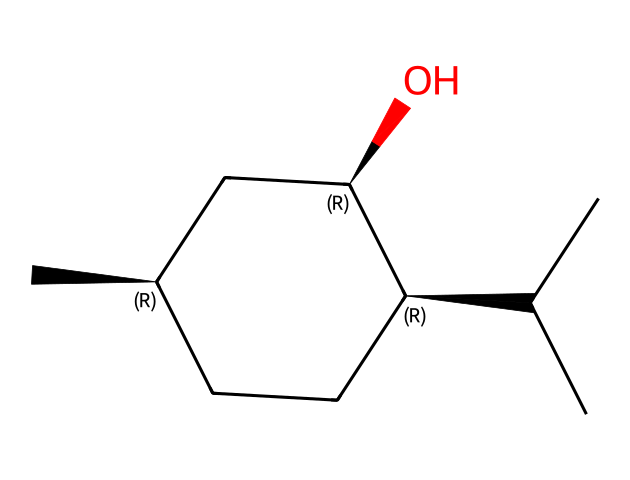How many carbon atoms are in menthol? The SMILES representation indicates 10 carbon atoms, which can be counted directly from the structure. Each "C" represents a carbon atom, and there are ten instances in total.
Answer: 10 What is the functional group present in menthol? The molecule contains a hydroxyl group (-OH) attached to one of the carbon atoms, indicating that it is an alcohol. The "O" in the SMILES structure signifies the presence of oxygen, and it's bonded to a carbon.
Answer: alcohol How many chiral centers are in menthol? By analyzing the structure, there are three chiral centers in menthol, indicated by the carbon atoms attached to four different groups or atoms. The sterochemistry indicators (@) in the SMILES represent these chiral centers.
Answer: 3 What type of stereoisomers can menthol exhibit? The presence of chiral centers in menthol allows it to exist as enantiomers, which are mirror images of each other. Since there are three chiral centers, the molecule can exhibit four stereoisomers in total (2^n, where n is the number of chiral centers).
Answer: enantiomers What is the primary use of menthol in products? Menthol is primarily used as a flavoring agent and cooling sensation enhancer in various products, including mint-flavored goods and personal care items. This usage can be derived from its significant presence in products designed to provide a minty flavor and cooling sensation.
Answer: flavoring agent Which characteristic of menthol contributes to its cooling effect? The presence of the hydroxyl group (-OH) and the specific arrangement of the carbon chain allow menthol to interact with cold receptors in the skin and mucous membranes, producing that characteristic cooling sensation. This effect is due to how menthol activates these receptors, identified through its molecular structure.
Answer: hydroxyl group 